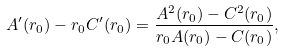<formula> <loc_0><loc_0><loc_500><loc_500>A ^ { \prime } ( r _ { 0 } ) - r _ { 0 } C ^ { \prime } ( r _ { 0 } ) = \frac { A ^ { 2 } ( r _ { 0 } ) - C ^ { 2 } ( r _ { 0 } ) } { r _ { 0 } A ( r _ { 0 } ) - C ( r _ { 0 } ) } ,</formula> 